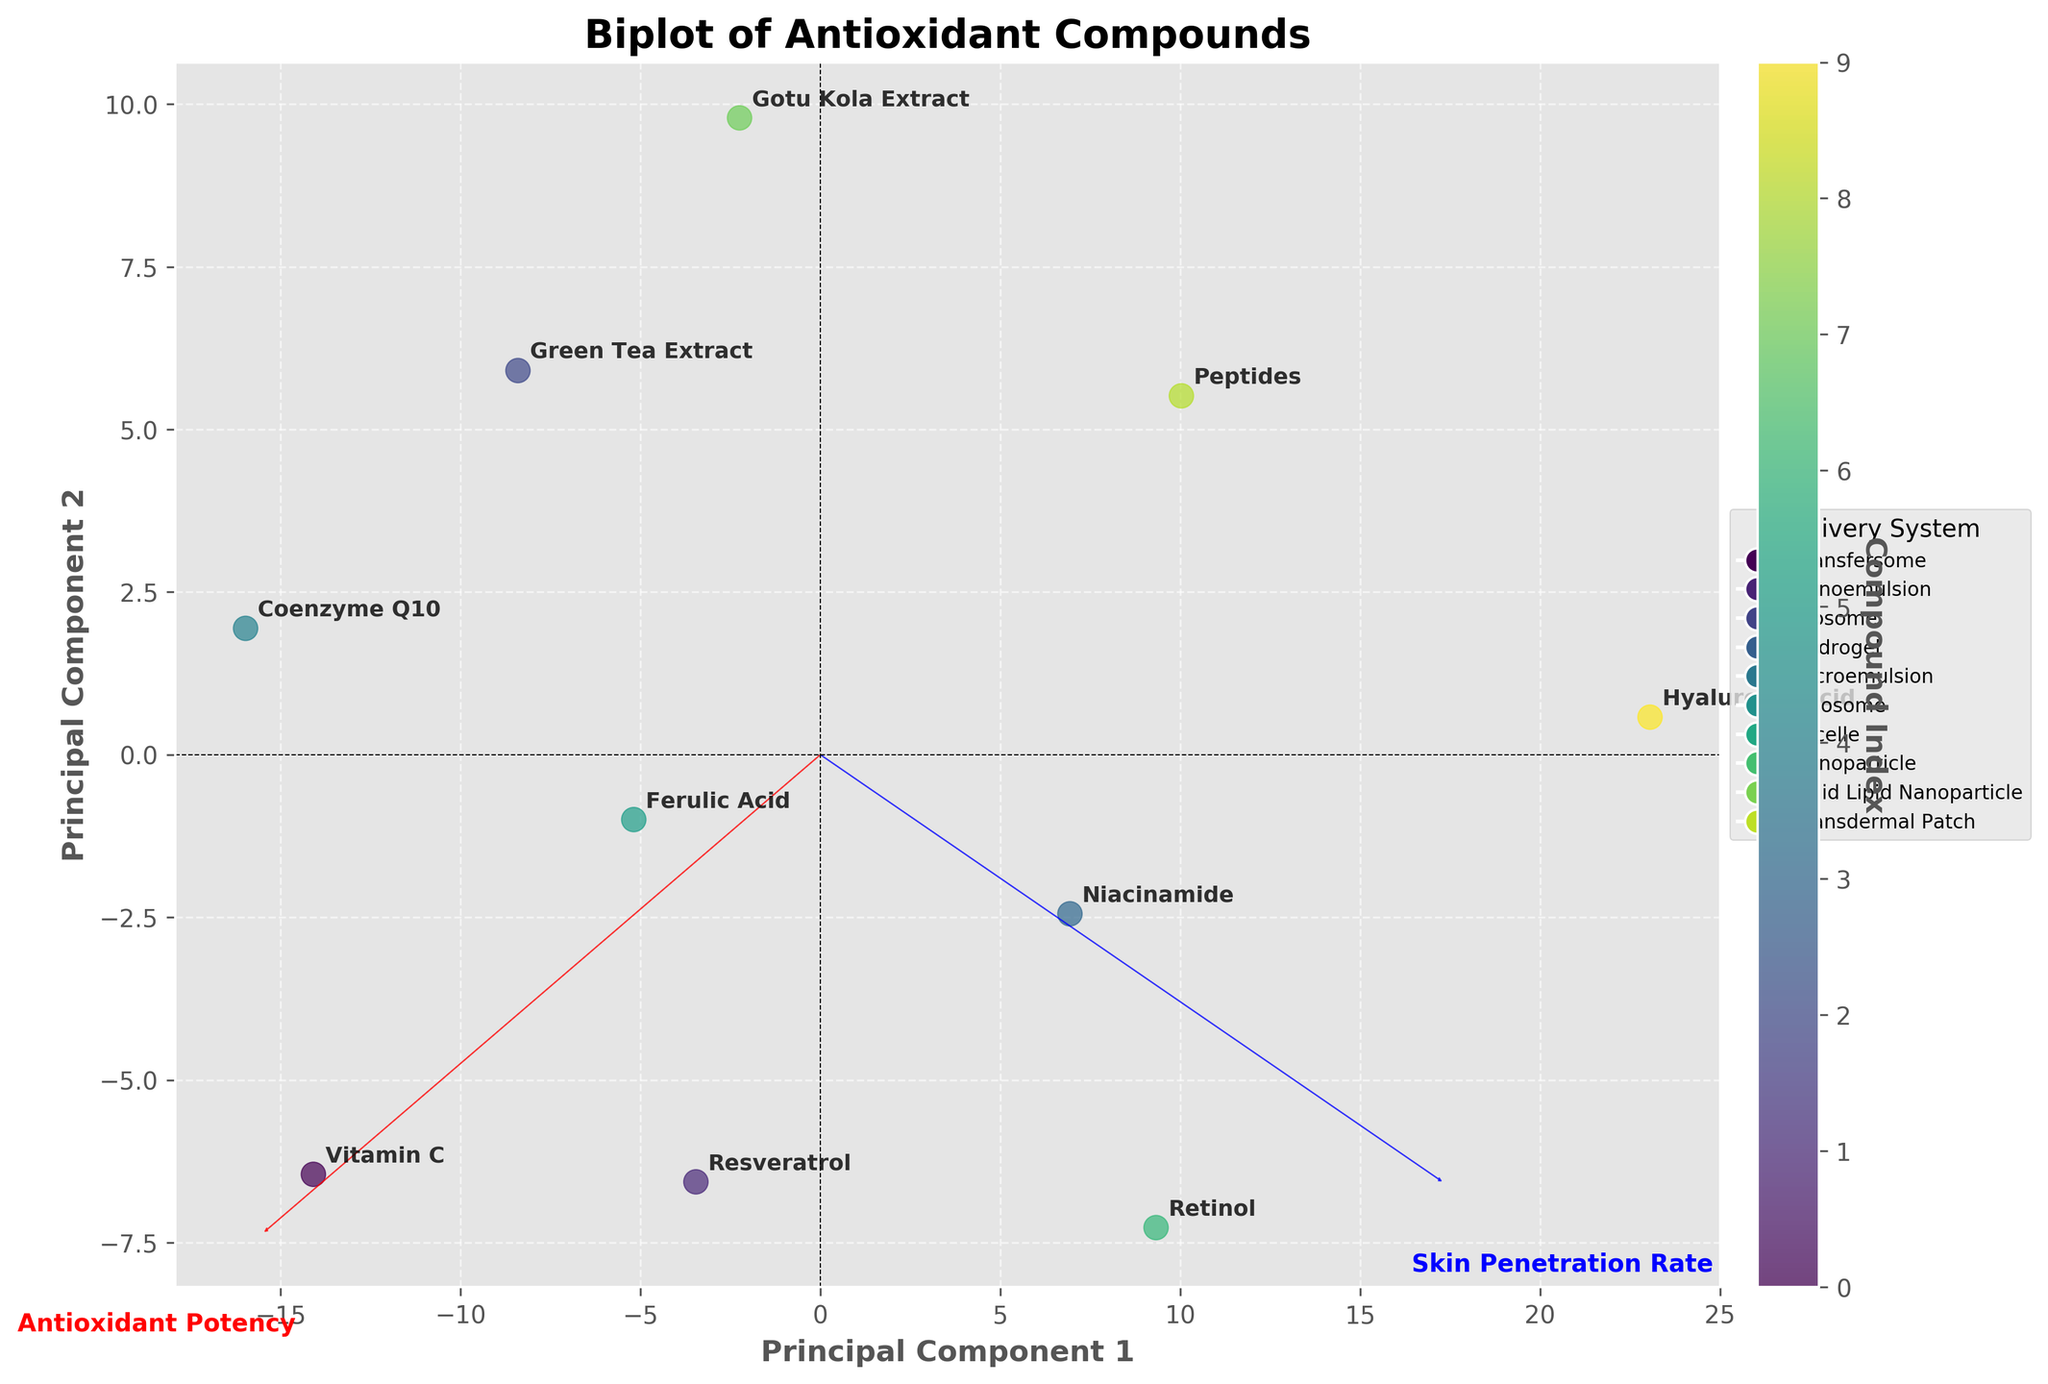How many compounds are represented in the figure? Count the number of distinct data points (or labels) visible on the plot. Each label represents a unique compound.
Answer: 10 Which compound has the highest antioxidant potency? Find the data point or label that is farthest along the axis associated with "Antioxidant Potency". This corresponds to the highest antioxidant potency value.
Answer: Vitamin C How do Vitamin C and Resveratrol compare in terms of skin penetration rate? Locate the positions of Vitamin C and Resveratrol on the plot. Compare their projections on the axis associated with "Skin Penetration Rate". Resveratrol is projected higher on this axis.
Answer: Resveratrol has a higher skin penetration rate What's the average skin penetration rate of Niacinamide and Retinol? Find the data points or labels for Niacinamide and Retinol on the plot and look at their positions on the axis associated with "Skin Penetration Rate". Average these two values: (75 + 80) / 2.
Answer: 77.5 Which delivery system is associated with the highest skin penetration rate, and which compound uses it? Look for the data point or label that is farthest along the axis associated with "Skin Penetration Rate" and see which delivery system it belongs to. The highest value is Hyaluronic Acid with a Transdermal Patch.
Answer: Transdermal Patch, Hyaluronic Acid Are the compounds clustered in any specific pattern concerning the "Antioxidant Potency" vector? Observe the distribution of data points along the axis associated with "Antioxidant Potency". Determine if there are noticeable groupings or patterns. Many of the high potency compounds are clustered together, while lower potency compounds are relatively spread out.
Answer: Yes, high potency compounds are clustered together Which compound shows a balanced performance in both antioxidant potency and skin penetration rate? Identify the compound that lies closer to the origin point where the vectors for "Antioxidant Potency" and "Skin Penetration Rate" intersect. Ferulic Acid is reasonably balanced.
Answer: Ferulic Acid What is the delivery system of the compound with the lowest antioxidant potency? Locate the data point or label with the lowest projection on the axis associated with "Antioxidant Potency". Then, identify its delivery system. The lowest antioxidant potency belongs to Hyaluronic Acid with a Transdermal Patch.
Answer: Transdermal Patch Between Retinol and Coenzyme Q10, which compound has a lower skin penetration rate? Find the data points or labels for Retinol and Coenzyme Q10 and compare their positions on the axis associated with "Skin Penetration Rate". Coenzyme Q10 is lower on this axis.
Answer: Coenzyme Q10 Which two delivery systems are closest in terms of their associated compound's skin penetration rates? Find and compare the positions of the labels of each delivery system on the axis associated with "Skin Penetration Rate". Look for the closest pair. Micelle (Ferulic Acid) and Liposome (Vitamin C) are closest.
Answer: Micelle and Liposome 